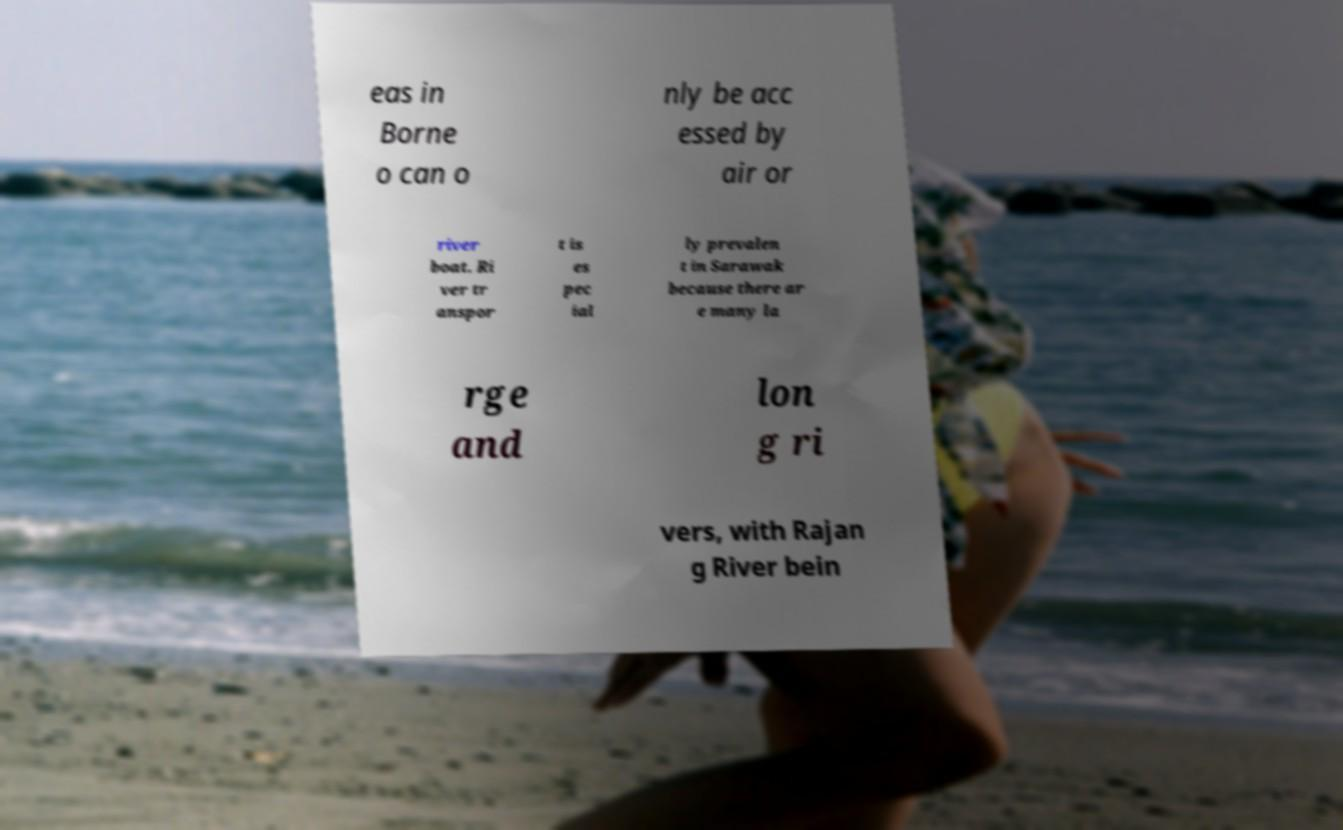For documentation purposes, I need the text within this image transcribed. Could you provide that? eas in Borne o can o nly be acc essed by air or river boat. Ri ver tr anspor t is es pec ial ly prevalen t in Sarawak because there ar e many la rge and lon g ri vers, with Rajan g River bein 